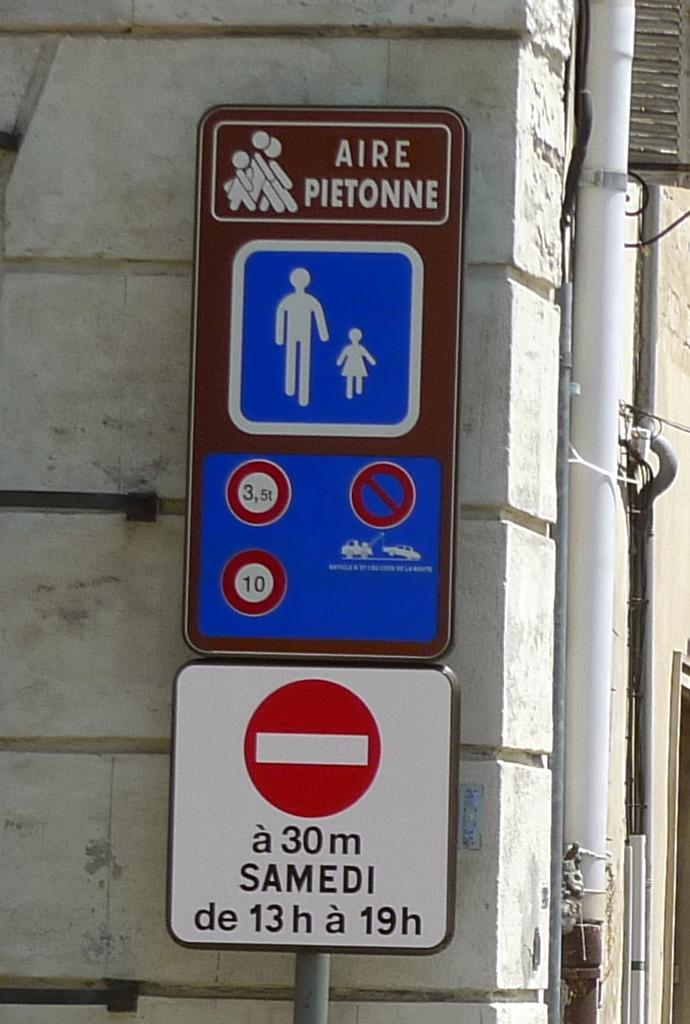<image>
Relay a brief, clear account of the picture shown. A multi colored sign reading Aire Pietonne in front of a grey brick wall. 